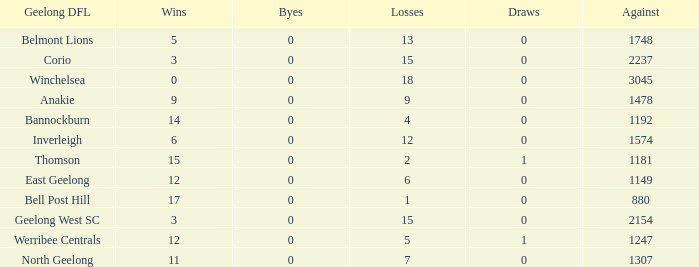What is the average of wins when the byes are less than 0? None. 